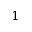<formula> <loc_0><loc_0><loc_500><loc_500>1</formula> 